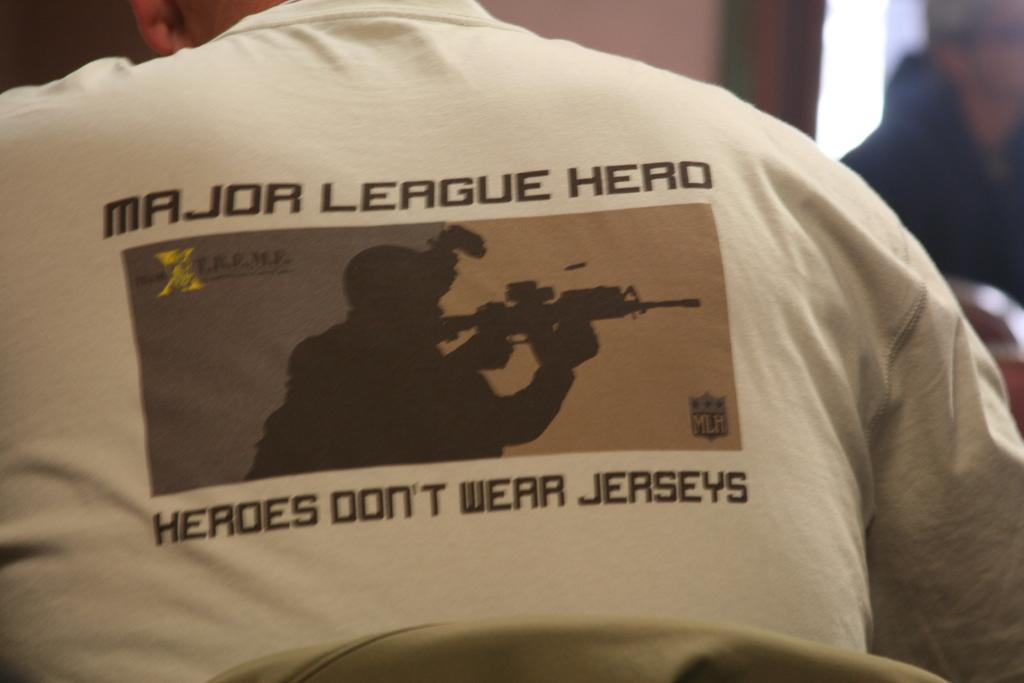What is the person in the image wearing? The person in the image is wearing a t-shirt. What can be seen on the t-shirt? The t-shirt has text on it. Can you describe the other person visible in the image? There is another person visible in the background of the image. How many oranges are being held by the person in the image? There are no oranges visible in the image. 